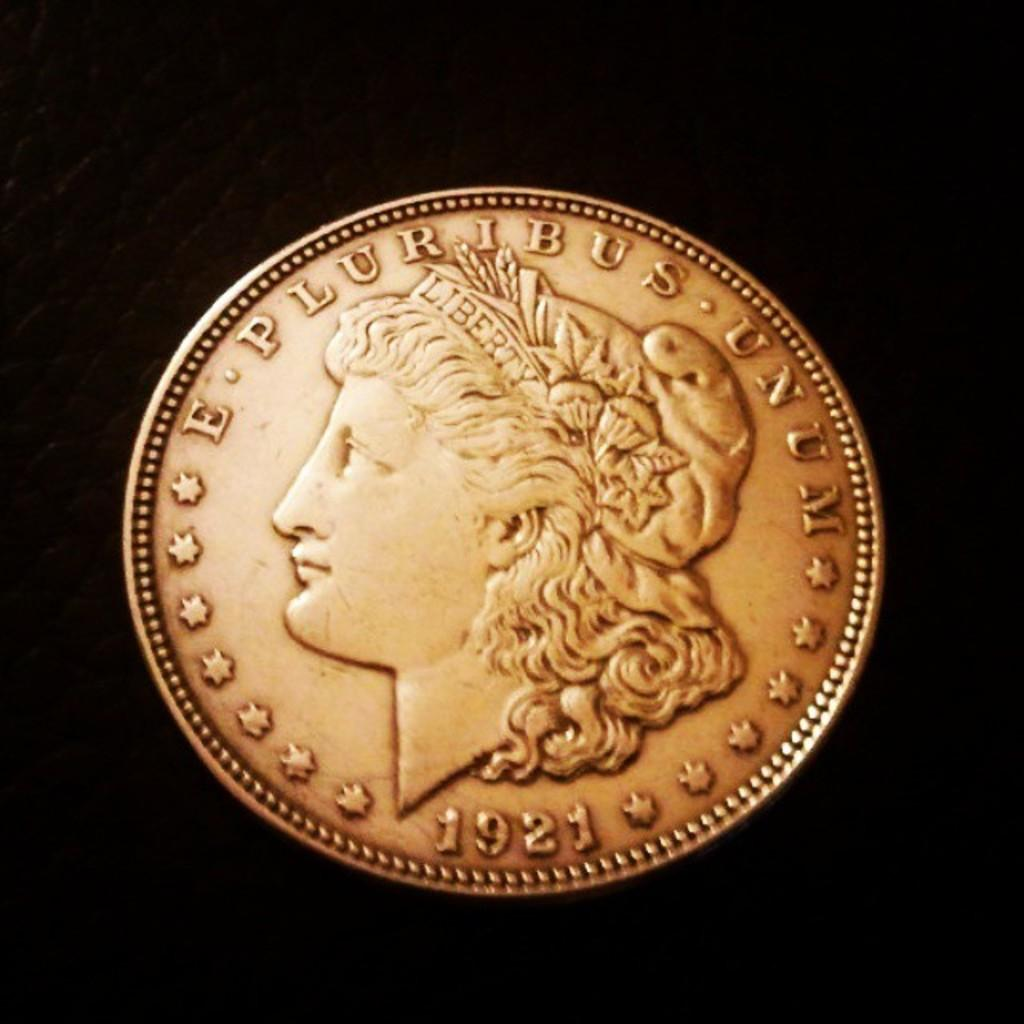What object is the main subject of the image? There is a coin in the image. What color is the background of the image? The background of the image is black. Can you see a donkey in the image? There is no donkey present in the image. What type of structure is visible in the image? There is no structure visible in the image; it only features a coin on a black background. 